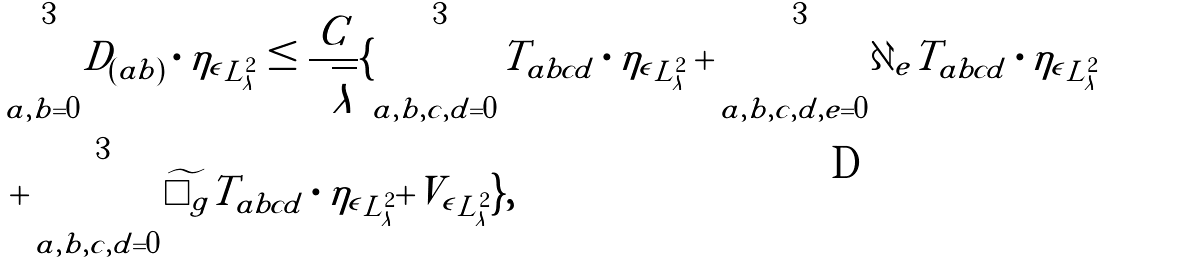<formula> <loc_0><loc_0><loc_500><loc_500>& \sum _ { a , b = 0 } ^ { 3 } | | D _ { ( a b ) } \cdot \eta _ { \epsilon } | | _ { L ^ { 2 } _ { \lambda } } \leq \frac { C } { \sqrt { \lambda } } \{ \sum _ { a , b , c , d = 0 } ^ { 3 } | | T _ { a b c d } \cdot \eta _ { \epsilon } | | _ { L ^ { 2 } _ { \lambda } } + \sum _ { a , b , c , d , e = 0 } ^ { 3 } | | \partial _ { e } T _ { a b c d } \cdot \eta _ { \epsilon } | | _ { L ^ { 2 } _ { \lambda } } \\ & + \sum _ { a , b , c , d = 0 } ^ { 3 } | | \widetilde { \Box _ { g } } T _ { a b c d } \cdot \eta _ { \epsilon } | | _ { L ^ { 2 } _ { \lambda } } + | | V _ { \epsilon } | | _ { L ^ { 2 } _ { \lambda } } \} ,</formula> 